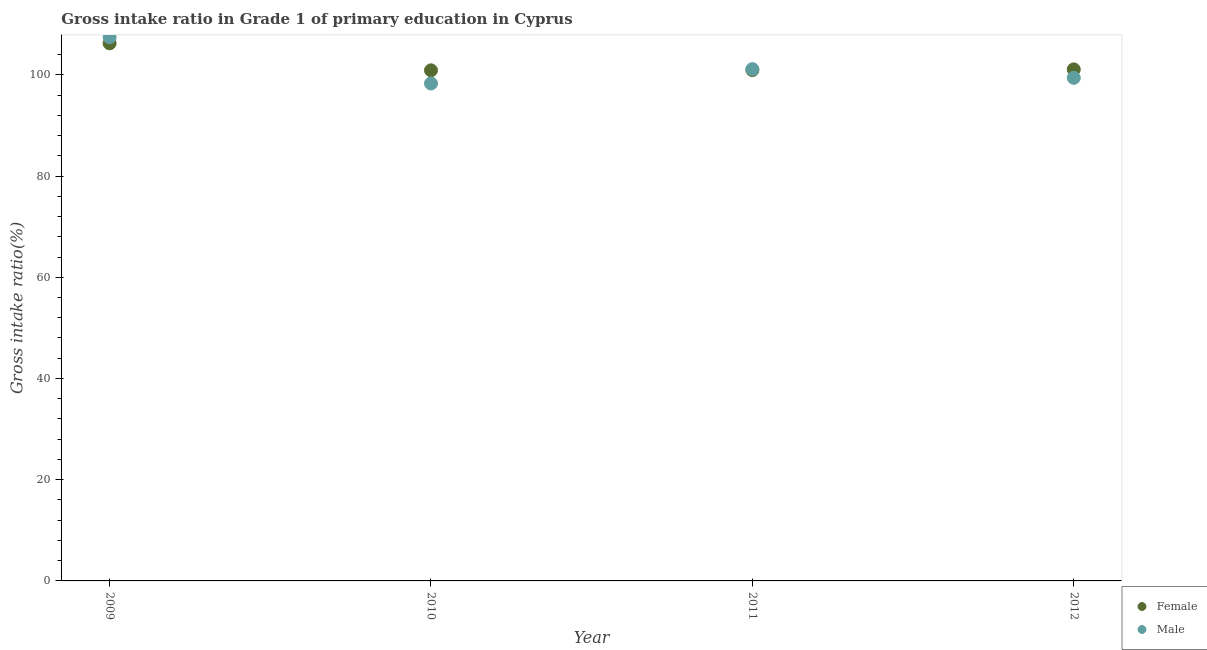What is the gross intake ratio(female) in 2009?
Your answer should be very brief. 106.23. Across all years, what is the maximum gross intake ratio(male)?
Your answer should be compact. 107.44. Across all years, what is the minimum gross intake ratio(female)?
Offer a very short reply. 100.89. What is the total gross intake ratio(female) in the graph?
Keep it short and to the point. 409.13. What is the difference between the gross intake ratio(male) in 2010 and that in 2012?
Ensure brevity in your answer.  -1.12. What is the difference between the gross intake ratio(male) in 2010 and the gross intake ratio(female) in 2012?
Your response must be concise. -2.78. What is the average gross intake ratio(male) per year?
Make the answer very short. 101.56. In the year 2011, what is the difference between the gross intake ratio(female) and gross intake ratio(male)?
Offer a terse response. -0.18. In how many years, is the gross intake ratio(male) greater than 100 %?
Your response must be concise. 2. What is the ratio of the gross intake ratio(male) in 2009 to that in 2010?
Offer a very short reply. 1.09. What is the difference between the highest and the second highest gross intake ratio(female)?
Give a very brief answer. 5.15. What is the difference between the highest and the lowest gross intake ratio(male)?
Offer a very short reply. 9.15. Is the gross intake ratio(male) strictly less than the gross intake ratio(female) over the years?
Your response must be concise. No. What is the difference between two consecutive major ticks on the Y-axis?
Offer a very short reply. 20. Are the values on the major ticks of Y-axis written in scientific E-notation?
Make the answer very short. No. Does the graph contain any zero values?
Give a very brief answer. No. What is the title of the graph?
Provide a succinct answer. Gross intake ratio in Grade 1 of primary education in Cyprus. Does "Male population" appear as one of the legend labels in the graph?
Your answer should be very brief. No. What is the label or title of the X-axis?
Your response must be concise. Year. What is the label or title of the Y-axis?
Keep it short and to the point. Gross intake ratio(%). What is the Gross intake ratio(%) of Female in 2009?
Keep it short and to the point. 106.23. What is the Gross intake ratio(%) of Male in 2009?
Give a very brief answer. 107.44. What is the Gross intake ratio(%) of Female in 2010?
Offer a very short reply. 100.89. What is the Gross intake ratio(%) of Male in 2010?
Your response must be concise. 98.29. What is the Gross intake ratio(%) in Female in 2011?
Provide a short and direct response. 100.94. What is the Gross intake ratio(%) in Male in 2011?
Your response must be concise. 101.12. What is the Gross intake ratio(%) of Female in 2012?
Provide a succinct answer. 101.07. What is the Gross intake ratio(%) of Male in 2012?
Ensure brevity in your answer.  99.41. Across all years, what is the maximum Gross intake ratio(%) of Female?
Keep it short and to the point. 106.23. Across all years, what is the maximum Gross intake ratio(%) in Male?
Your answer should be very brief. 107.44. Across all years, what is the minimum Gross intake ratio(%) in Female?
Your answer should be compact. 100.89. Across all years, what is the minimum Gross intake ratio(%) in Male?
Make the answer very short. 98.29. What is the total Gross intake ratio(%) in Female in the graph?
Provide a succinct answer. 409.13. What is the total Gross intake ratio(%) in Male in the graph?
Provide a succinct answer. 406.26. What is the difference between the Gross intake ratio(%) in Female in 2009 and that in 2010?
Provide a short and direct response. 5.34. What is the difference between the Gross intake ratio(%) in Male in 2009 and that in 2010?
Offer a terse response. 9.15. What is the difference between the Gross intake ratio(%) in Female in 2009 and that in 2011?
Provide a succinct answer. 5.28. What is the difference between the Gross intake ratio(%) in Male in 2009 and that in 2011?
Provide a succinct answer. 6.31. What is the difference between the Gross intake ratio(%) in Female in 2009 and that in 2012?
Provide a short and direct response. 5.15. What is the difference between the Gross intake ratio(%) in Male in 2009 and that in 2012?
Provide a short and direct response. 8.03. What is the difference between the Gross intake ratio(%) in Female in 2010 and that in 2011?
Keep it short and to the point. -0.06. What is the difference between the Gross intake ratio(%) of Male in 2010 and that in 2011?
Offer a terse response. -2.83. What is the difference between the Gross intake ratio(%) in Female in 2010 and that in 2012?
Your response must be concise. -0.19. What is the difference between the Gross intake ratio(%) of Male in 2010 and that in 2012?
Provide a succinct answer. -1.12. What is the difference between the Gross intake ratio(%) of Female in 2011 and that in 2012?
Give a very brief answer. -0.13. What is the difference between the Gross intake ratio(%) in Male in 2011 and that in 2012?
Provide a succinct answer. 1.71. What is the difference between the Gross intake ratio(%) in Female in 2009 and the Gross intake ratio(%) in Male in 2010?
Your answer should be compact. 7.94. What is the difference between the Gross intake ratio(%) of Female in 2009 and the Gross intake ratio(%) of Male in 2011?
Provide a short and direct response. 5.11. What is the difference between the Gross intake ratio(%) of Female in 2009 and the Gross intake ratio(%) of Male in 2012?
Provide a short and direct response. 6.82. What is the difference between the Gross intake ratio(%) of Female in 2010 and the Gross intake ratio(%) of Male in 2011?
Keep it short and to the point. -0.24. What is the difference between the Gross intake ratio(%) in Female in 2010 and the Gross intake ratio(%) in Male in 2012?
Offer a very short reply. 1.48. What is the difference between the Gross intake ratio(%) in Female in 2011 and the Gross intake ratio(%) in Male in 2012?
Make the answer very short. 1.53. What is the average Gross intake ratio(%) of Female per year?
Your answer should be very brief. 102.28. What is the average Gross intake ratio(%) of Male per year?
Provide a short and direct response. 101.56. In the year 2009, what is the difference between the Gross intake ratio(%) of Female and Gross intake ratio(%) of Male?
Ensure brevity in your answer.  -1.21. In the year 2010, what is the difference between the Gross intake ratio(%) in Female and Gross intake ratio(%) in Male?
Give a very brief answer. 2.6. In the year 2011, what is the difference between the Gross intake ratio(%) in Female and Gross intake ratio(%) in Male?
Offer a terse response. -0.18. In the year 2012, what is the difference between the Gross intake ratio(%) in Female and Gross intake ratio(%) in Male?
Provide a short and direct response. 1.66. What is the ratio of the Gross intake ratio(%) in Female in 2009 to that in 2010?
Give a very brief answer. 1.05. What is the ratio of the Gross intake ratio(%) of Male in 2009 to that in 2010?
Make the answer very short. 1.09. What is the ratio of the Gross intake ratio(%) in Female in 2009 to that in 2011?
Your response must be concise. 1.05. What is the ratio of the Gross intake ratio(%) of Male in 2009 to that in 2011?
Ensure brevity in your answer.  1.06. What is the ratio of the Gross intake ratio(%) of Female in 2009 to that in 2012?
Make the answer very short. 1.05. What is the ratio of the Gross intake ratio(%) in Male in 2009 to that in 2012?
Your response must be concise. 1.08. What is the ratio of the Gross intake ratio(%) of Male in 2010 to that in 2011?
Give a very brief answer. 0.97. What is the ratio of the Gross intake ratio(%) in Female in 2010 to that in 2012?
Give a very brief answer. 1. What is the ratio of the Gross intake ratio(%) in Male in 2010 to that in 2012?
Provide a short and direct response. 0.99. What is the ratio of the Gross intake ratio(%) in Female in 2011 to that in 2012?
Ensure brevity in your answer.  1. What is the ratio of the Gross intake ratio(%) of Male in 2011 to that in 2012?
Your response must be concise. 1.02. What is the difference between the highest and the second highest Gross intake ratio(%) of Female?
Offer a very short reply. 5.15. What is the difference between the highest and the second highest Gross intake ratio(%) of Male?
Ensure brevity in your answer.  6.31. What is the difference between the highest and the lowest Gross intake ratio(%) of Female?
Offer a very short reply. 5.34. What is the difference between the highest and the lowest Gross intake ratio(%) of Male?
Provide a short and direct response. 9.15. 